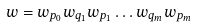<formula> <loc_0><loc_0><loc_500><loc_500>w = w _ { p _ { 0 } } w _ { q _ { 1 } } w _ { p _ { 1 } } \dots w _ { q _ { m } } w _ { p _ { m } }</formula> 